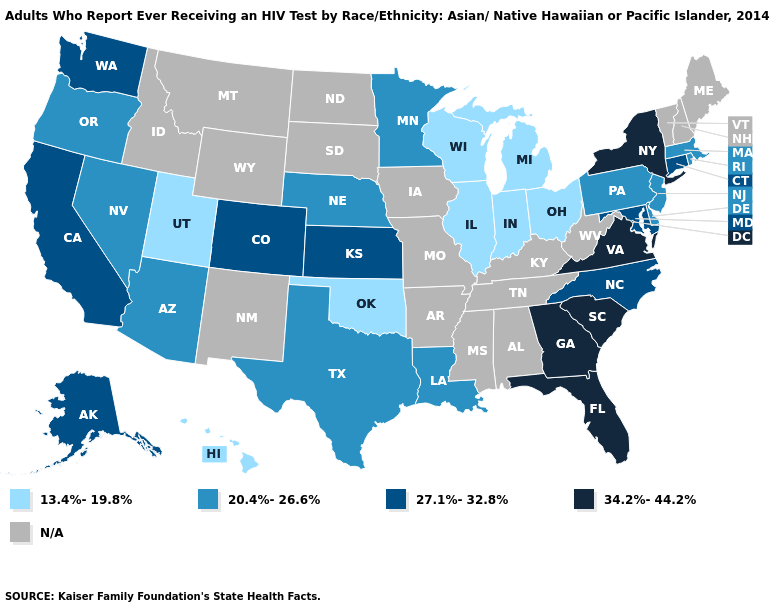How many symbols are there in the legend?
Quick response, please. 5. Is the legend a continuous bar?
Quick response, please. No. Which states hav the highest value in the South?
Short answer required. Florida, Georgia, South Carolina, Virginia. Which states have the lowest value in the USA?
Write a very short answer. Hawaii, Illinois, Indiana, Michigan, Ohio, Oklahoma, Utah, Wisconsin. What is the value of California?
Concise answer only. 27.1%-32.8%. What is the lowest value in states that border New York?
Short answer required. 20.4%-26.6%. Name the states that have a value in the range 20.4%-26.6%?
Be succinct. Arizona, Delaware, Louisiana, Massachusetts, Minnesota, Nebraska, Nevada, New Jersey, Oregon, Pennsylvania, Rhode Island, Texas. Does the map have missing data?
Give a very brief answer. Yes. Name the states that have a value in the range 20.4%-26.6%?
Concise answer only. Arizona, Delaware, Louisiana, Massachusetts, Minnesota, Nebraska, Nevada, New Jersey, Oregon, Pennsylvania, Rhode Island, Texas. Does the first symbol in the legend represent the smallest category?
Write a very short answer. Yes. What is the highest value in the USA?
Short answer required. 34.2%-44.2%. Does the first symbol in the legend represent the smallest category?
Concise answer only. Yes. Is the legend a continuous bar?
Short answer required. No. What is the value of Georgia?
Give a very brief answer. 34.2%-44.2%. Does Virginia have the highest value in the USA?
Quick response, please. Yes. 